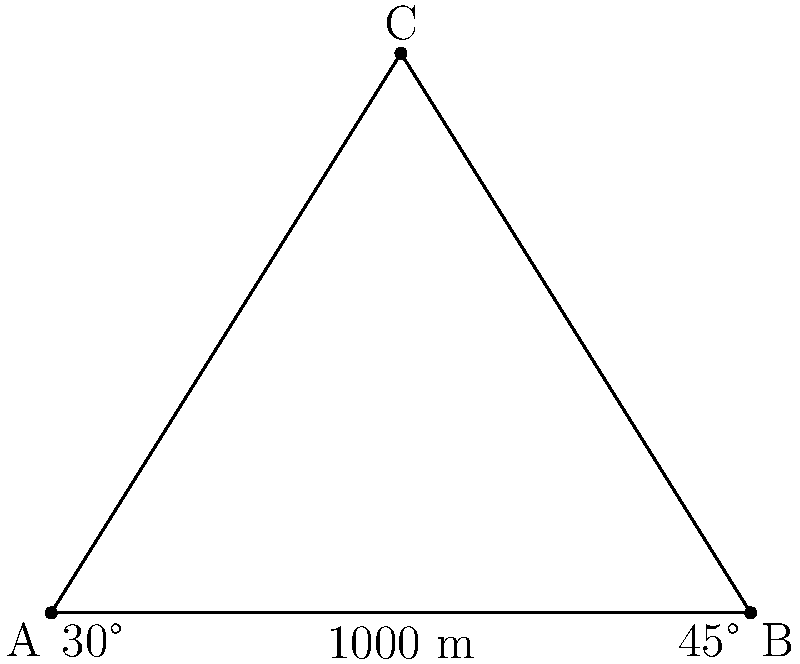You're on a hiking trip and notice two mountain peaks, A and B, with a valley between them. From your viewpoint C, you measure the angle between the two peaks to be 45°. The angle of elevation to peak A is 30°, and the distance between the two peaks is 1000 meters. How high is peak B above peak A? Let's approach this step-by-step:

1) First, we need to find the height of peak A relative to our position. We can use the tangent function:

   $\tan(30°) = \frac{\text{height of A}}{\text{half the distance between A and B}}$

2) We know the distance between A and B is 1000 m, so half of that is 500 m.

   $\tan(30°) = \frac{\text{height of A}}{500}$

3) Solving for the height of A:

   $\text{height of A} = 500 \cdot \tan(30°) = 500 \cdot \frac{\sqrt{3}}{3} \approx 288.68$ m

4) Now, we need to find the height of B. We can use the tangent of 45° for this:

   $\tan(45°) = \frac{\text{height of B}}{\text{half the distance between A and B}} = \frac{\text{height of B}}{500}$

5) Solving for the height of B:

   $\text{height of B} = 500 \cdot \tan(45°) = 500 \cdot 1 = 500$ m

6) The difference in height between B and A is:

   $500 - 288.68 = 211.32$ m

Therefore, peak B is approximately 211.32 meters higher than peak A.
Answer: 211.32 meters 